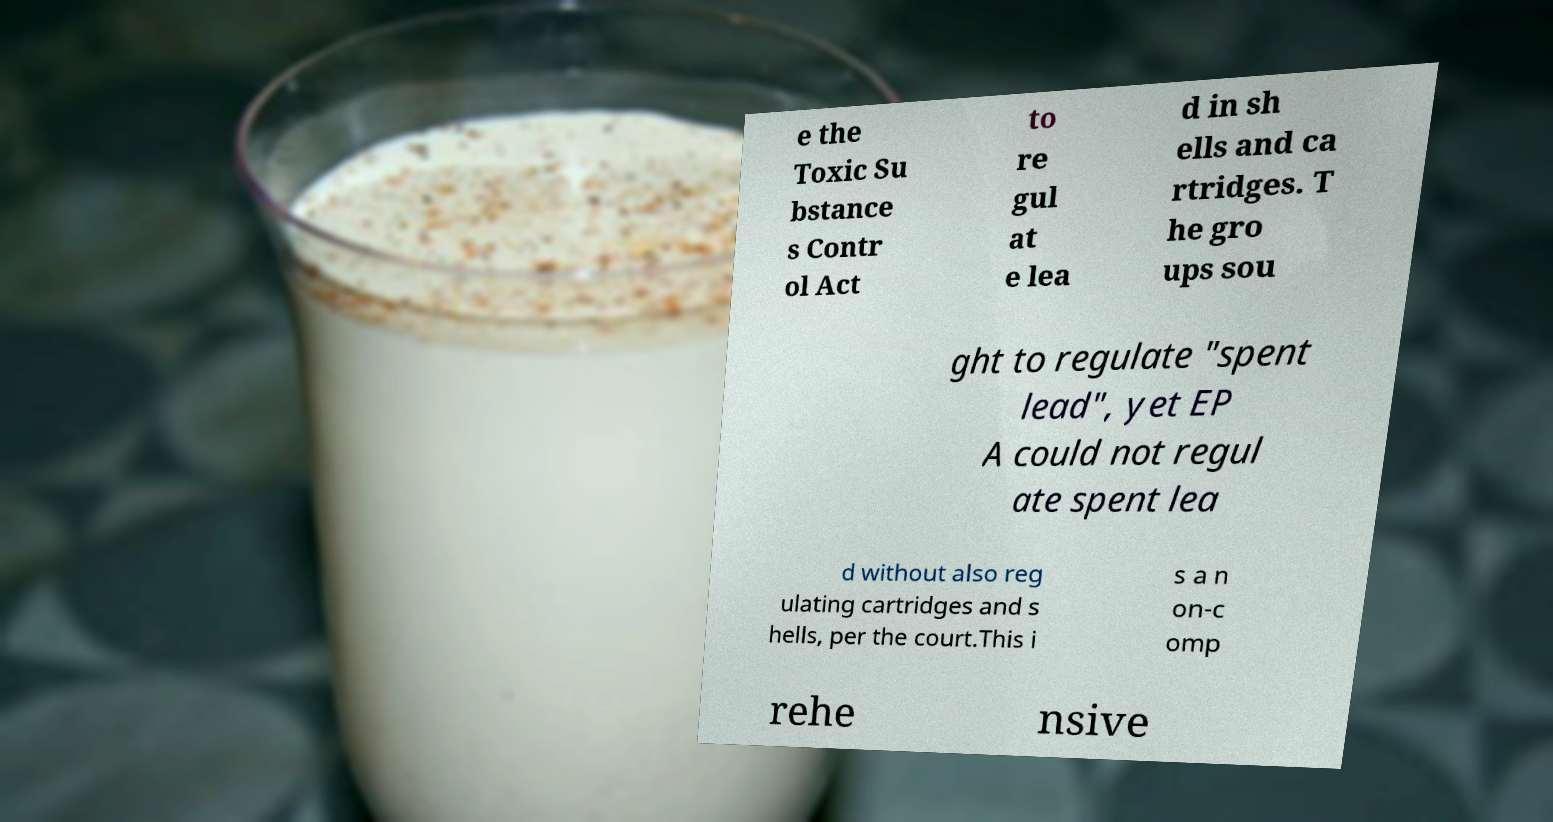I need the written content from this picture converted into text. Can you do that? e the Toxic Su bstance s Contr ol Act to re gul at e lea d in sh ells and ca rtridges. T he gro ups sou ght to regulate "spent lead", yet EP A could not regul ate spent lea d without also reg ulating cartridges and s hells, per the court.This i s a n on-c omp rehe nsive 